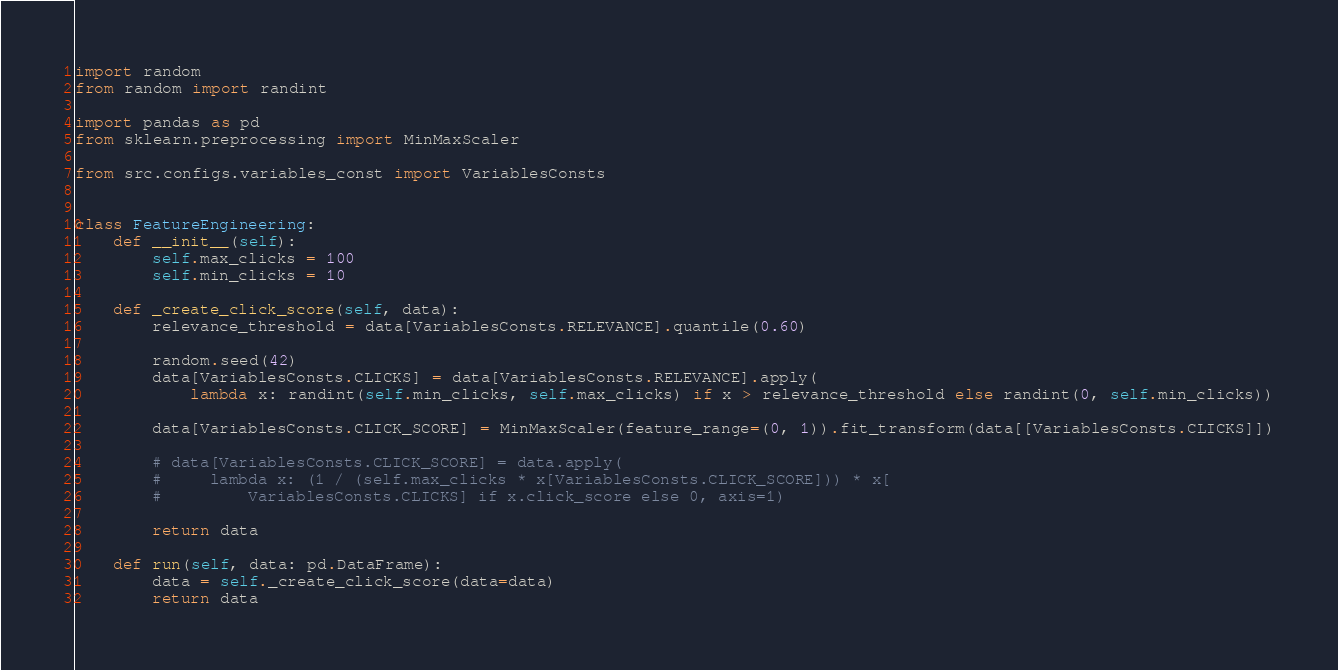Convert code to text. <code><loc_0><loc_0><loc_500><loc_500><_Python_>import random
from random import randint

import pandas as pd
from sklearn.preprocessing import MinMaxScaler

from src.configs.variables_const import VariablesConsts


class FeatureEngineering:
    def __init__(self):
        self.max_clicks = 100
        self.min_clicks = 10

    def _create_click_score(self, data):
        relevance_threshold = data[VariablesConsts.RELEVANCE].quantile(0.60)

        random.seed(42)
        data[VariablesConsts.CLICKS] = data[VariablesConsts.RELEVANCE].apply(
            lambda x: randint(self.min_clicks, self.max_clicks) if x > relevance_threshold else randint(0, self.min_clicks))

        data[VariablesConsts.CLICK_SCORE] = MinMaxScaler(feature_range=(0, 1)).fit_transform(data[[VariablesConsts.CLICKS]])

        # data[VariablesConsts.CLICK_SCORE] = data.apply(
        #     lambda x: (1 / (self.max_clicks * x[VariablesConsts.CLICK_SCORE])) * x[
        #         VariablesConsts.CLICKS] if x.click_score else 0, axis=1)

        return data

    def run(self, data: pd.DataFrame):
        data = self._create_click_score(data=data)
        return data
</code> 